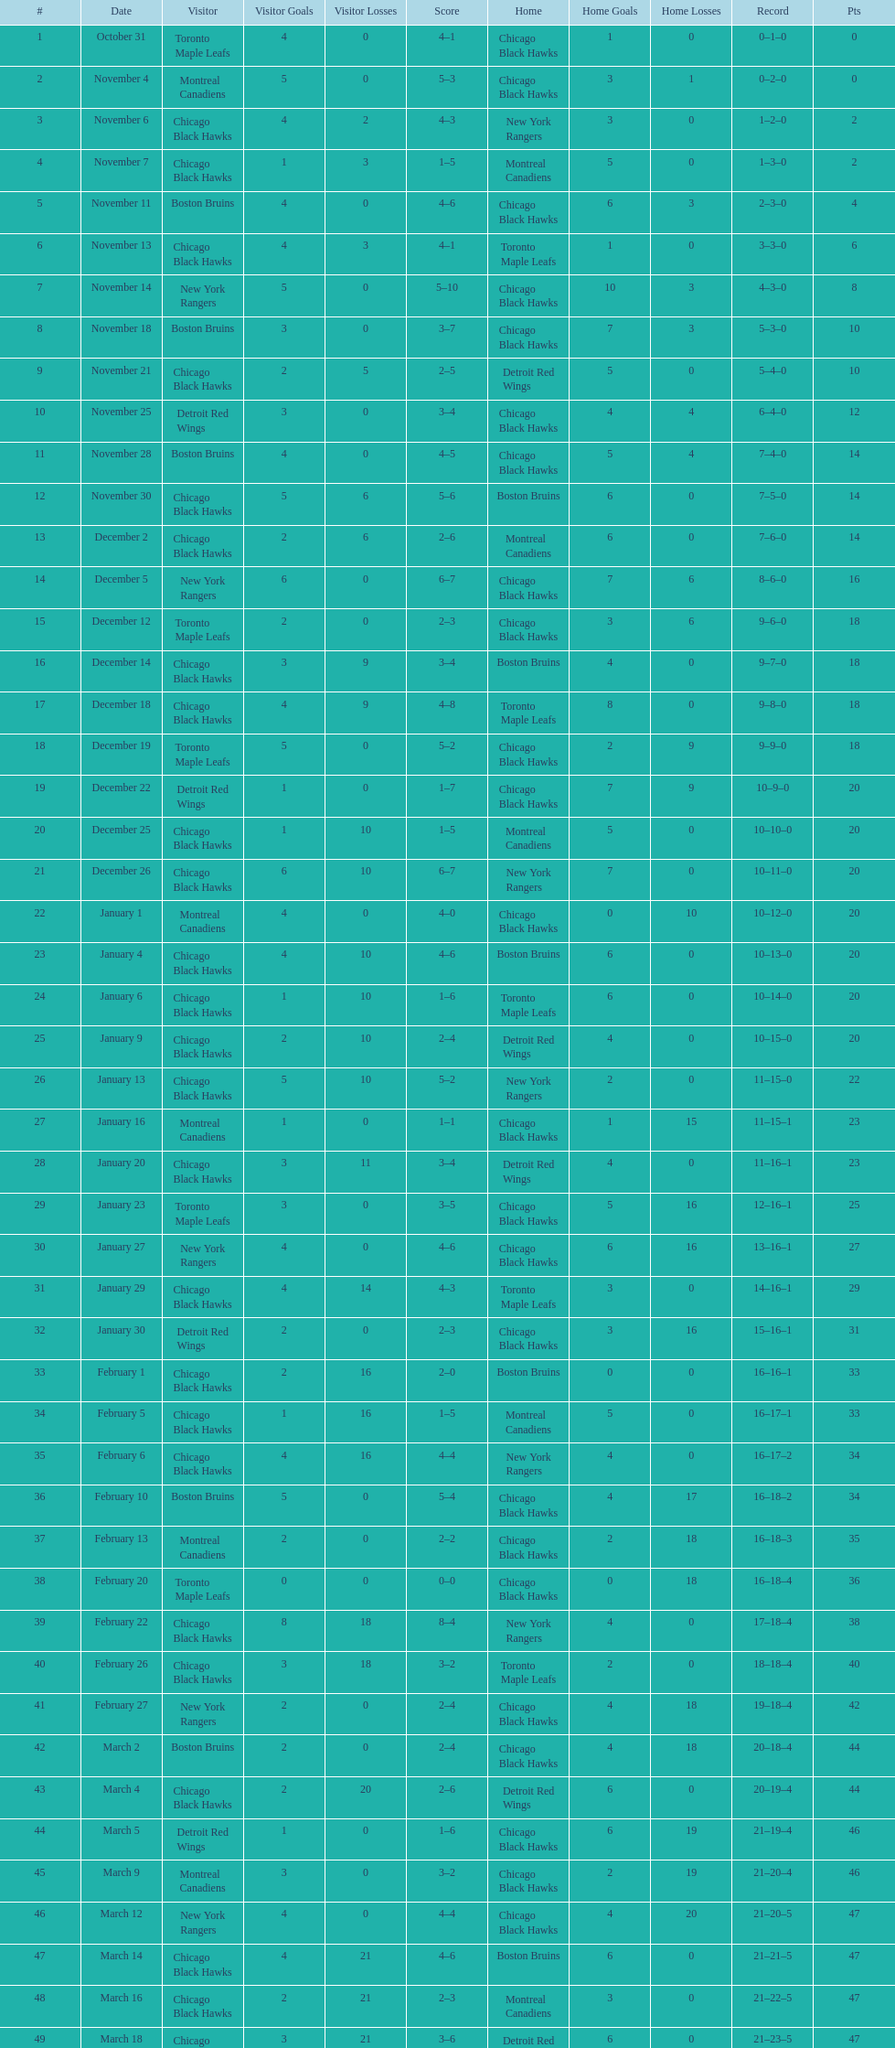What is the total number of games played? 50. 